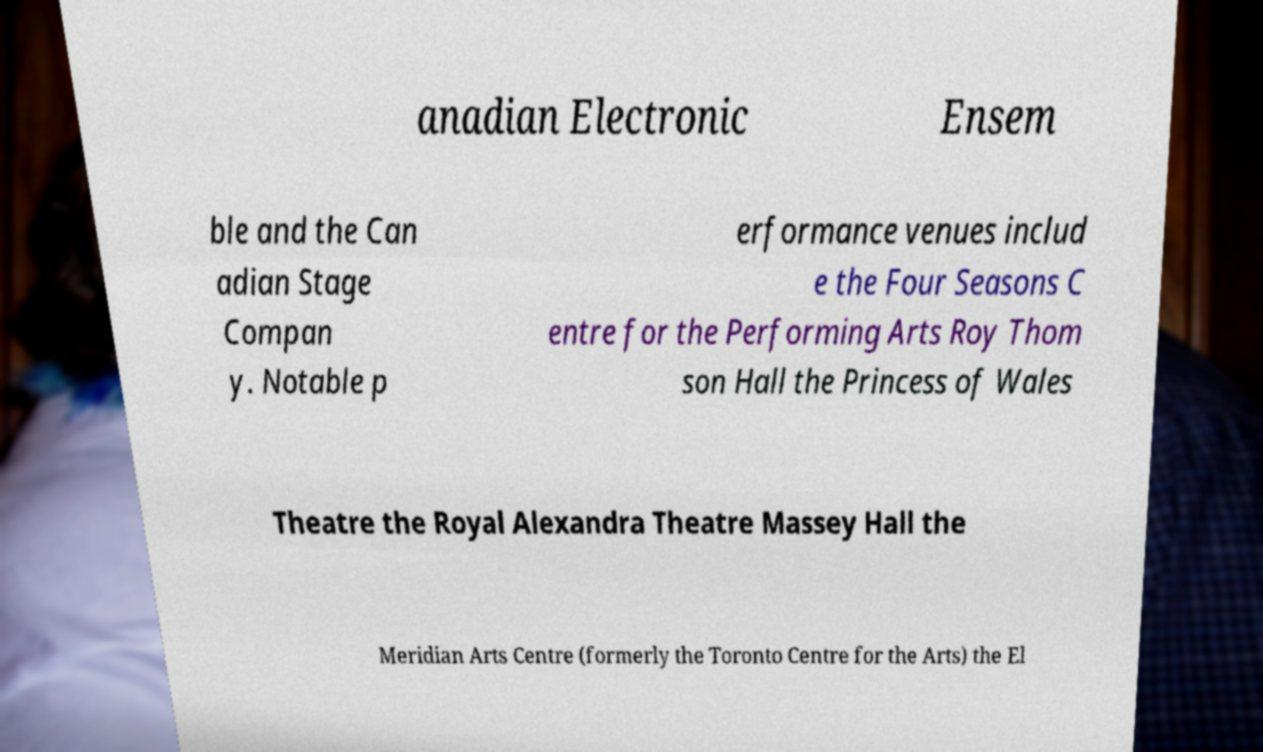Can you read and provide the text displayed in the image?This photo seems to have some interesting text. Can you extract and type it out for me? anadian Electronic Ensem ble and the Can adian Stage Compan y. Notable p erformance venues includ e the Four Seasons C entre for the Performing Arts Roy Thom son Hall the Princess of Wales Theatre the Royal Alexandra Theatre Massey Hall the Meridian Arts Centre (formerly the Toronto Centre for the Arts) the El 